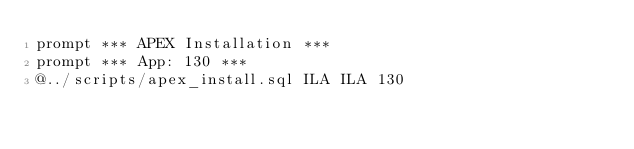Convert code to text. <code><loc_0><loc_0><loc_500><loc_500><_SQL_>prompt *** APEX Installation ***
prompt *** App: 130 ***
@../scripts/apex_install.sql ILA ILA 130
</code> 